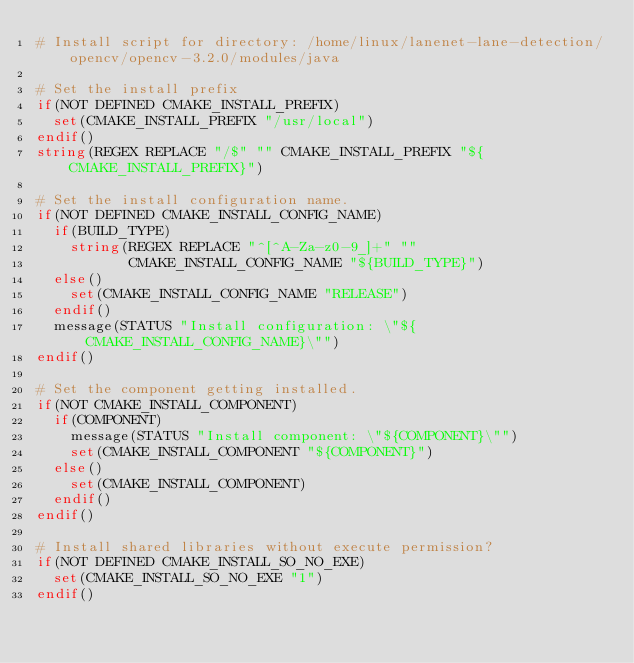Convert code to text. <code><loc_0><loc_0><loc_500><loc_500><_CMake_># Install script for directory: /home/linux/lanenet-lane-detection/opencv/opencv-3.2.0/modules/java

# Set the install prefix
if(NOT DEFINED CMAKE_INSTALL_PREFIX)
  set(CMAKE_INSTALL_PREFIX "/usr/local")
endif()
string(REGEX REPLACE "/$" "" CMAKE_INSTALL_PREFIX "${CMAKE_INSTALL_PREFIX}")

# Set the install configuration name.
if(NOT DEFINED CMAKE_INSTALL_CONFIG_NAME)
  if(BUILD_TYPE)
    string(REGEX REPLACE "^[^A-Za-z0-9_]+" ""
           CMAKE_INSTALL_CONFIG_NAME "${BUILD_TYPE}")
  else()
    set(CMAKE_INSTALL_CONFIG_NAME "RELEASE")
  endif()
  message(STATUS "Install configuration: \"${CMAKE_INSTALL_CONFIG_NAME}\"")
endif()

# Set the component getting installed.
if(NOT CMAKE_INSTALL_COMPONENT)
  if(COMPONENT)
    message(STATUS "Install component: \"${COMPONENT}\"")
    set(CMAKE_INSTALL_COMPONENT "${COMPONENT}")
  else()
    set(CMAKE_INSTALL_COMPONENT)
  endif()
endif()

# Install shared libraries without execute permission?
if(NOT DEFINED CMAKE_INSTALL_SO_NO_EXE)
  set(CMAKE_INSTALL_SO_NO_EXE "1")
endif()

</code> 